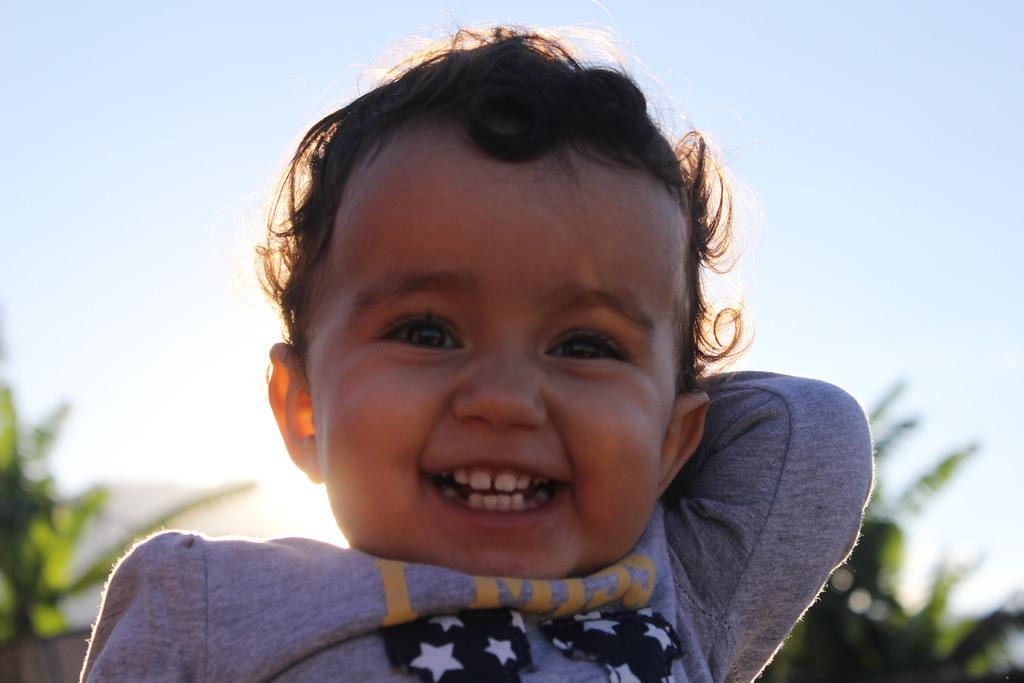What is the main subject of the picture? The main subject of the picture is a kid. What is the kid doing in the image? The kid is smiling in the image. Can you describe the background of the image? The background of the image is blurred, but there are trees and the sun visible. What is the condition of the sky in the image? The sky is clear in the image. What type of dress is the kid wearing in the image? There is no information about the kid's clothing in the image, so we cannot determine if they are wearing a dress or not. How many kittens are playing with the kid in the image? There are no kittens present in the image; it only features a kid. 